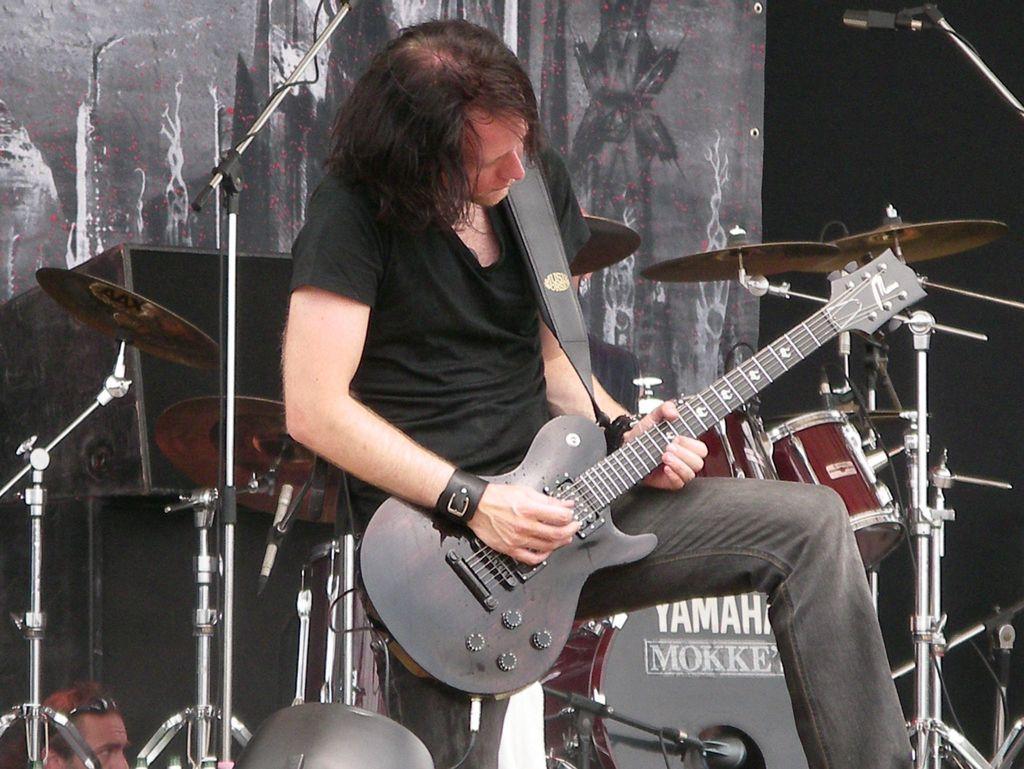How would you summarize this image in a sentence or two? In this picture I can see a man sitting and holding a guitar, there are mikes stands, speakers, there are drums, cymbals with the cymbals stands, and in the background there is a banner. 